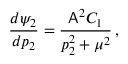<formula> <loc_0><loc_0><loc_500><loc_500>\frac { d \psi _ { 2 } } { d p _ { 2 } } = \frac { A ^ { 2 } C _ { 1 } } { p _ { 2 } ^ { 2 } + \mu ^ { 2 } } \, ,</formula> 